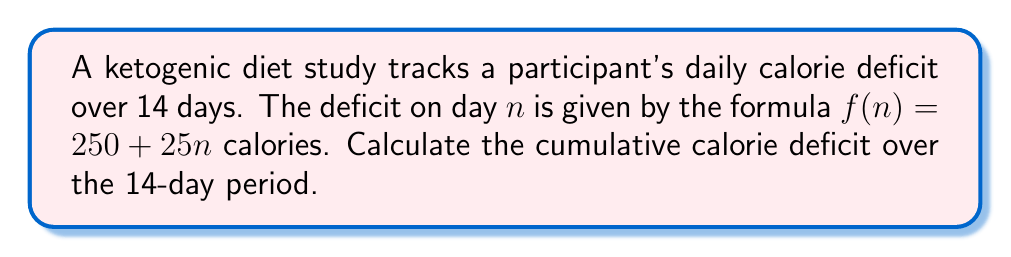Solve this math problem. To solve this problem, we need to find the sum of the daily calorie deficits over 14 days. Let's approach this step-by-step:

1) The calorie deficit for each day is given by the formula:
   $f(n) = 250 + 25n$, where $n$ is the day number (1 to 14)

2) We need to sum this for all 14 days:
   $\sum_{n=1}^{14} (250 + 25n)$

3) This can be split into two sums:
   $\sum_{n=1}^{14} 250 + \sum_{n=1}^{14} 25n$

4) For the first sum:
   $\sum_{n=1}^{14} 250 = 250 \times 14 = 3500$

5) For the second sum, we can use the formula for the sum of an arithmetic sequence:
   $\sum_{n=1}^{n} n = \frac{n(n+1)}{2}$

   So, $\sum_{n=1}^{14} 25n = 25 \times \sum_{n=1}^{14} n = 25 \times \frac{14(14+1)}{2} = 25 \times \frac{14 \times 15}{2} = 25 \times 105 = 2625$

6) Adding the results from steps 4 and 5:
   $3500 + 2625 = 6125$

Therefore, the cumulative calorie deficit over the 14-day period is 6125 calories.
Answer: 6125 calories 